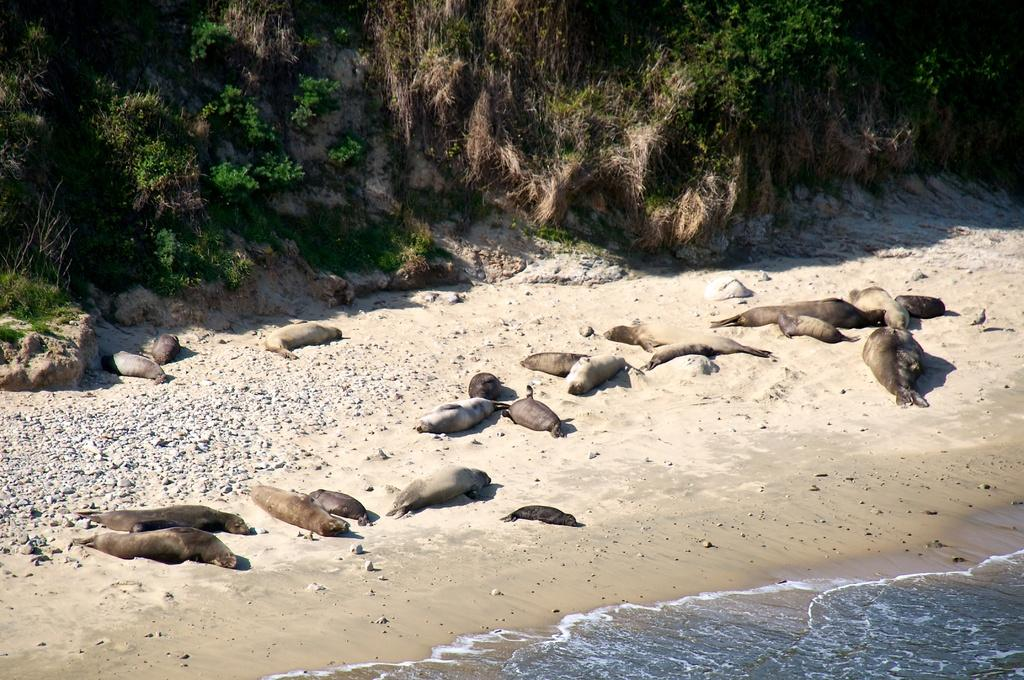What type of animals can be seen in the image? There are seals in the image. What type of terrain is visible in the image? There is sand and stones visible in the image. What is the water like in the image? There is water visible in the image. What type of vegetation can be seen in the background of the image? There is grass and leaves in the background of the image. How many cubs are playing with the seals in the image? There are no cubs present in the image; it features seals on a sandy and stony terrain with water and vegetation in the background. What type of need is being used to sew the leaves together in the image? There is no sewing or needles present in the image; it features seals, sand, stones, water, and vegetation. 